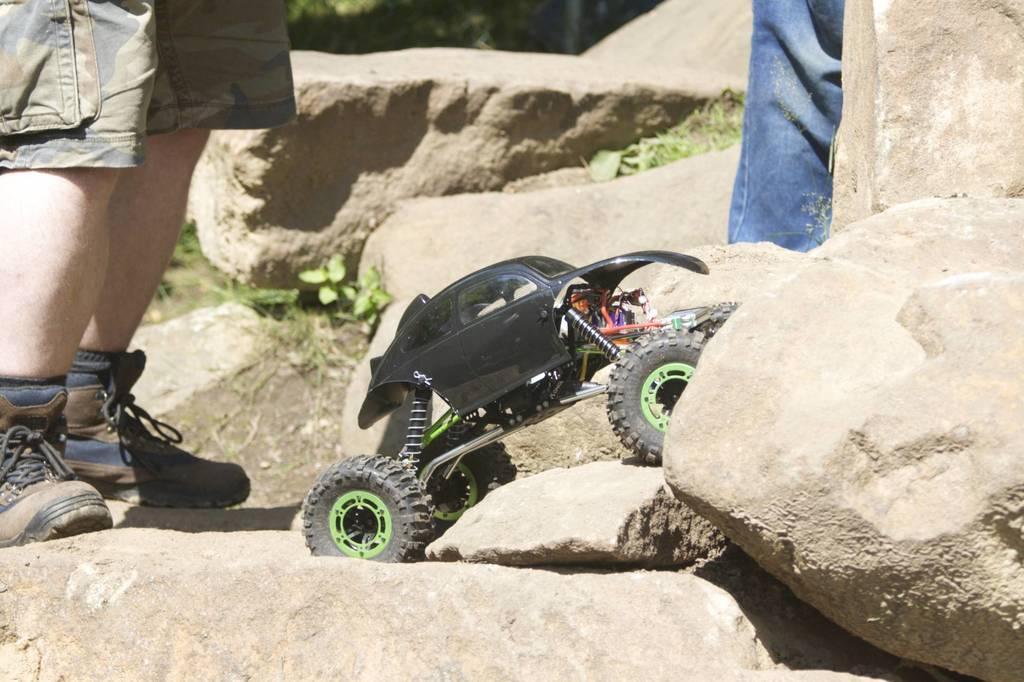Can you describe this image briefly? At the bottom of the picture, we see the rocks and a toy vehicle in black color. On the left side, we see a person is standing. On the right side, we see a person wearing a blue jeans is standing. There are herbs and trees in the background. 